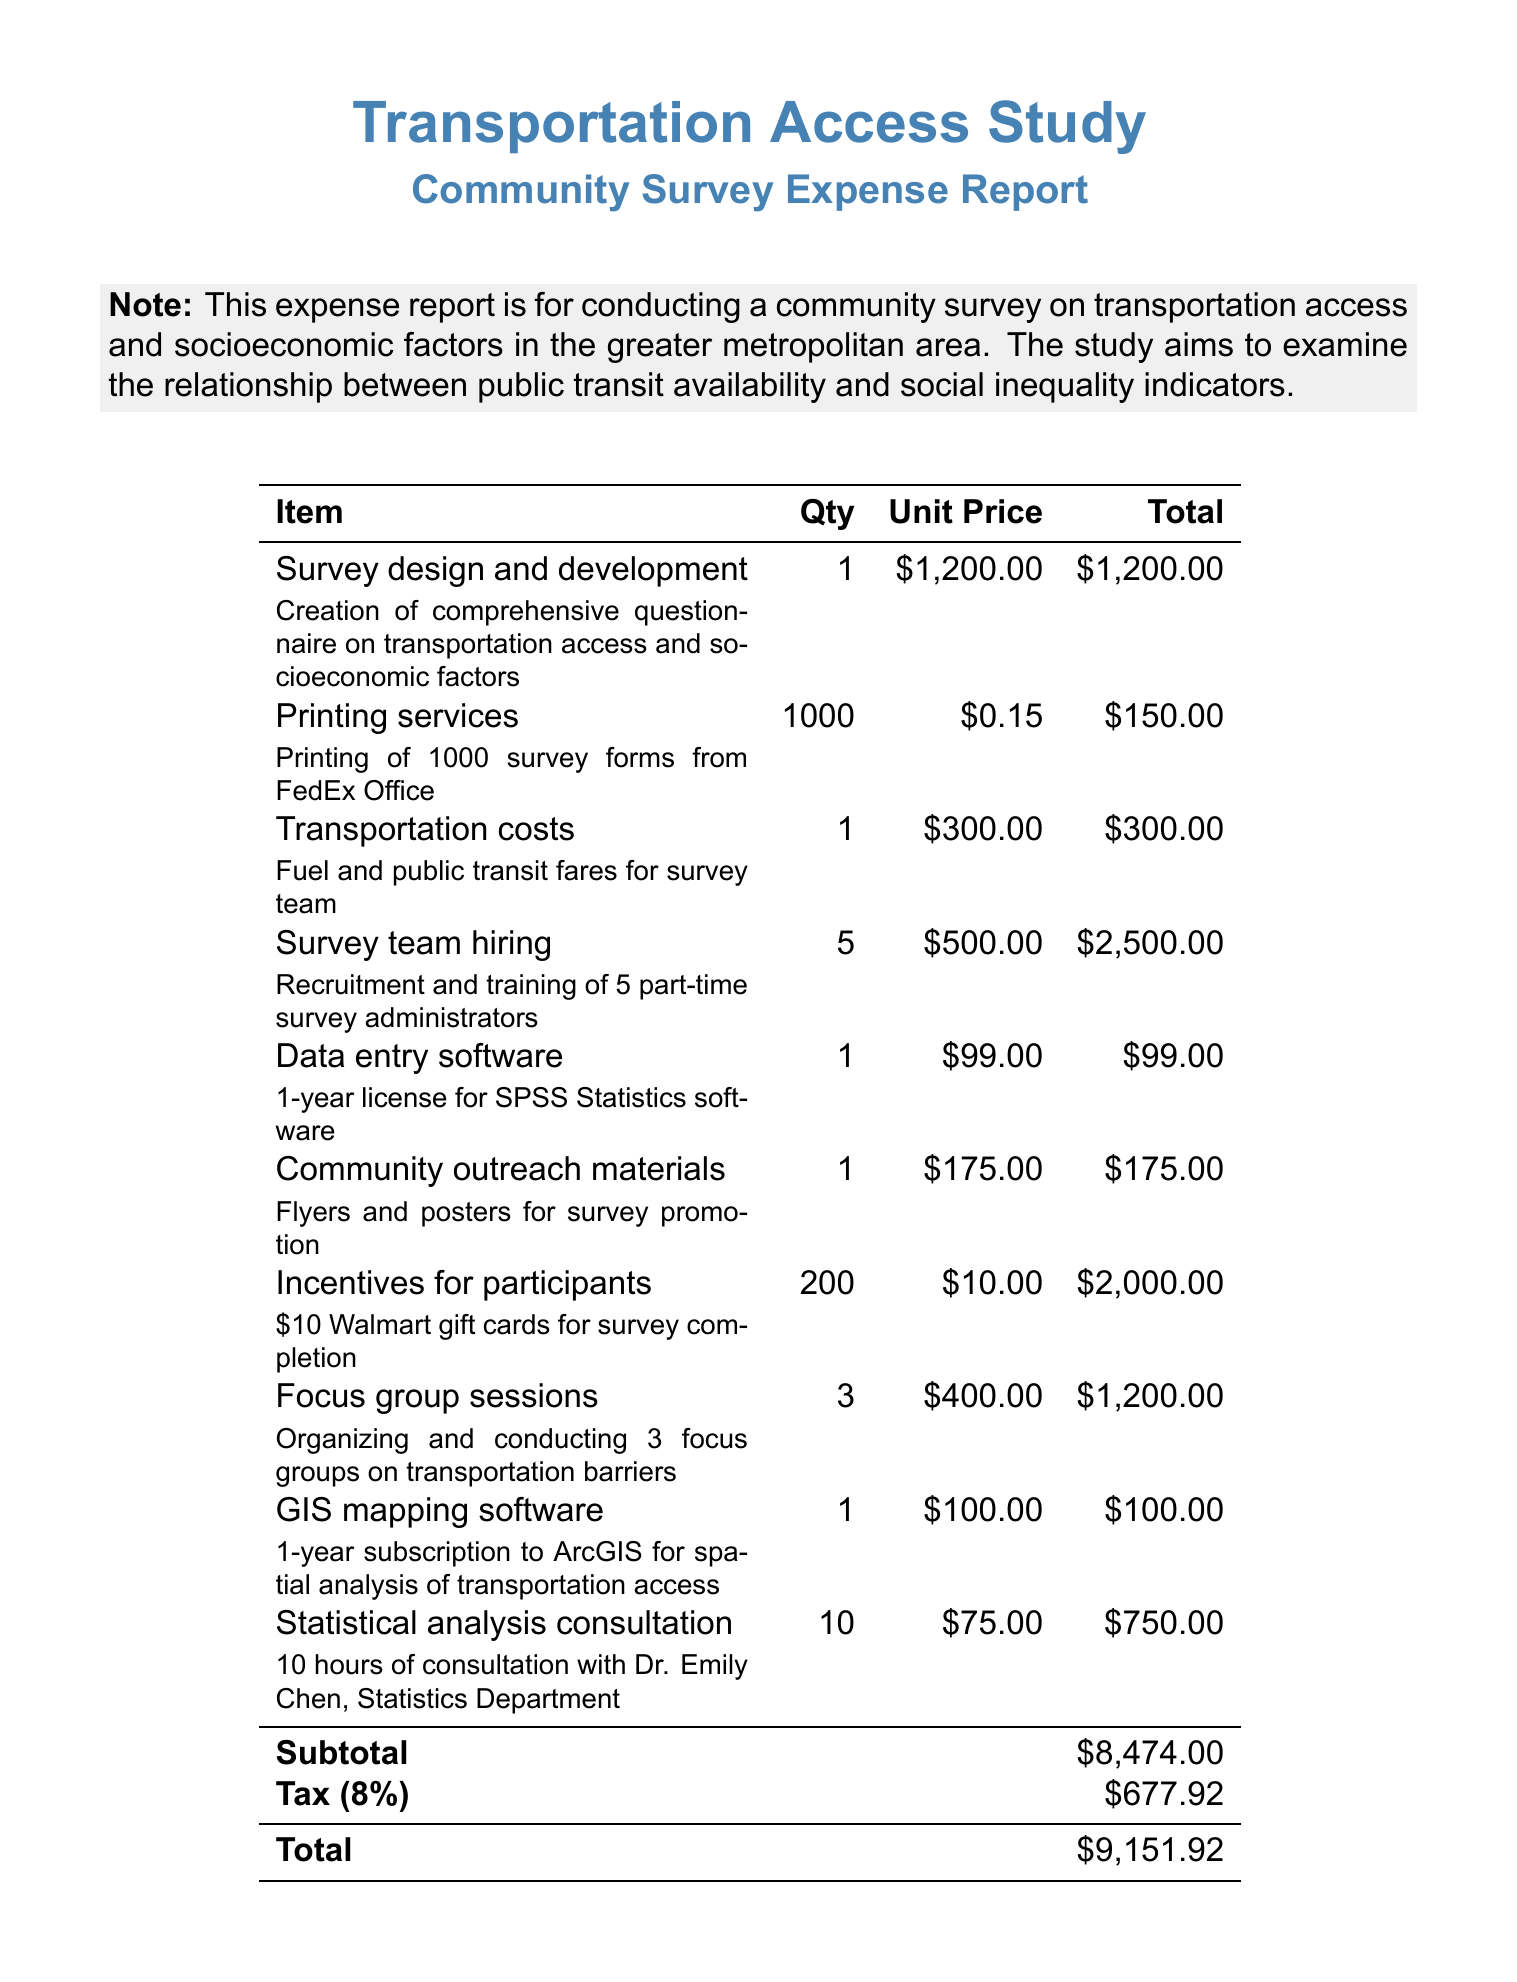What is the total cost of the survey design and development? The total cost for survey design and development is indicated in the invoice as $1,200.00.
Answer: $1,200.00 How many survey team members were hired? The invoice specifies that 5 part-time survey administrators were hired for the survey.
Answer: 5 What is the quantity of printing services? The quantity for printing services is stated as 1000 survey forms printed.
Answer: 1000 What is the tax amount for this invoice? The document lists the tax amount as 8% of the subtotal, which totals $677.92.
Answer: $677.92 What software license is included in the expenses? The document mentions a 1-year license for SPSS Statistics software as part of the expenses.
Answer: SPSS Statistics What item accounts for the highest expense? The invoice indicates that the highest expense is for survey team hiring, totaling $2,500.00.
Answer: $2,500.00 What is the total of the invoice? The total amount due on the invoice, including tax, is $9,151.92.
Answer: $9,151.92 How many focus groups were conducted? The invoice states that 3 focus groups were organized and conducted regarding transportation barriers.
Answer: 3 What is the purpose of the community survey? The invoice mentions that the investigation aims to examine the relationship between public transit availability and social inequality indicators.
Answer: Examine the relationship между transportation access and social inequality 